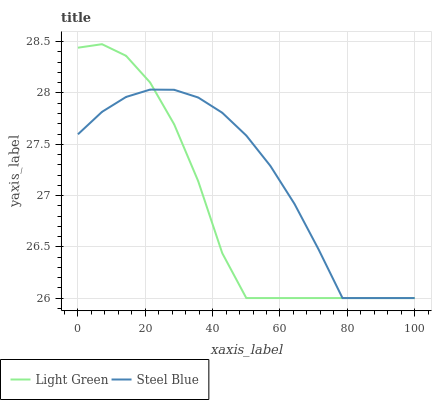Does Light Green have the minimum area under the curve?
Answer yes or no. Yes. Does Steel Blue have the maximum area under the curve?
Answer yes or no. Yes. Does Light Green have the maximum area under the curve?
Answer yes or no. No. Is Steel Blue the smoothest?
Answer yes or no. Yes. Is Light Green the roughest?
Answer yes or no. Yes. Is Light Green the smoothest?
Answer yes or no. No. Does Steel Blue have the lowest value?
Answer yes or no. Yes. Does Light Green have the highest value?
Answer yes or no. Yes. Does Light Green intersect Steel Blue?
Answer yes or no. Yes. Is Light Green less than Steel Blue?
Answer yes or no. No. Is Light Green greater than Steel Blue?
Answer yes or no. No. 